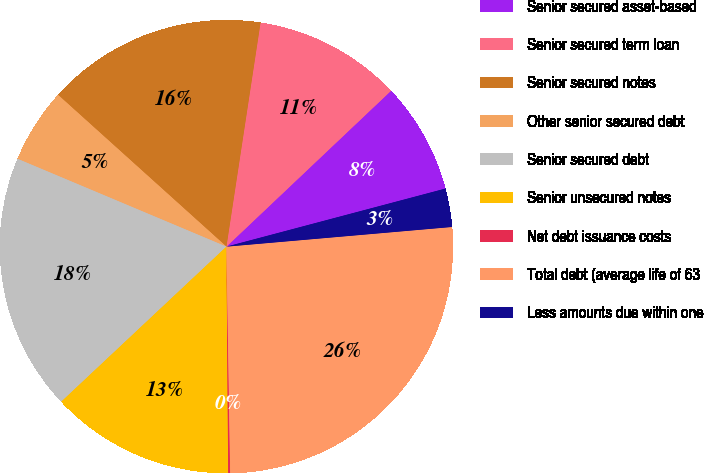<chart> <loc_0><loc_0><loc_500><loc_500><pie_chart><fcel>Senior secured asset-based<fcel>Senior secured term loan<fcel>Senior secured notes<fcel>Other senior secured debt<fcel>Senior secured debt<fcel>Senior unsecured notes<fcel>Net debt issuance costs<fcel>Total debt (average life of 63<fcel>Less amounts due within one<nl><fcel>7.94%<fcel>10.53%<fcel>15.73%<fcel>5.34%<fcel>18.33%<fcel>13.13%<fcel>0.14%<fcel>26.12%<fcel>2.74%<nl></chart> 